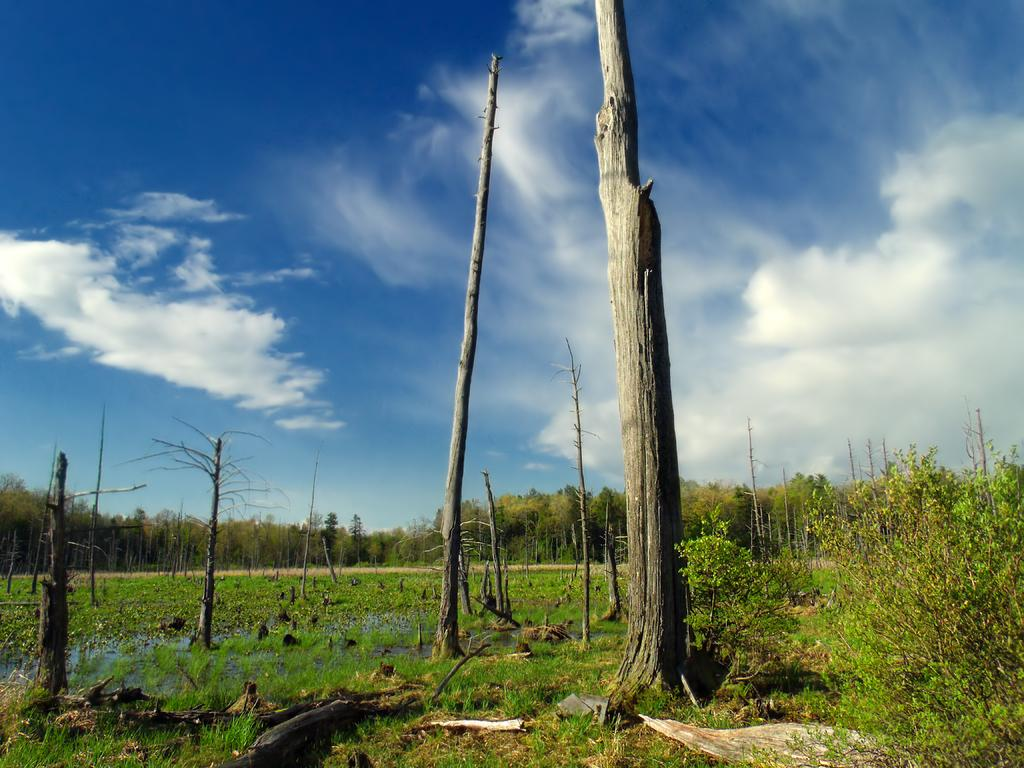What type of vegetation can be seen in the image? There are trees, tree trunks, plants, and grass in the image. What is on the ground in the image? There are sticks on the ground in the image. What is visible in the sky in the image? There are clouds in the sky in the image. What color is the territory in the image? There is no territory present in the image; it features natural elements such as trees, plants, and grass. How does the wind cause the leaves to fall in the image? There is no wind or falling leaves depicted in the image; it shows trees, plants, and grass in a static state. 